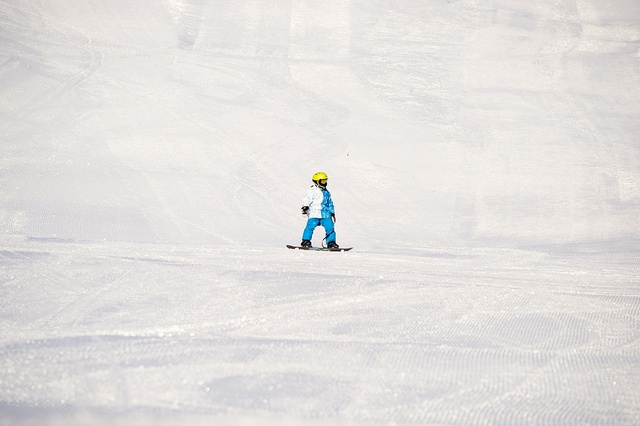Describe the objects in this image and their specific colors. I can see people in lightgray, white, teal, black, and blue tones and snowboard in lightgray, gray, darkgray, and black tones in this image. 